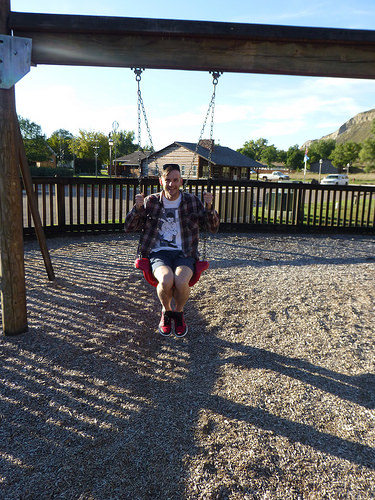<image>
Can you confirm if the girl is on the swing? Yes. Looking at the image, I can see the girl is positioned on top of the swing, with the swing providing support. 